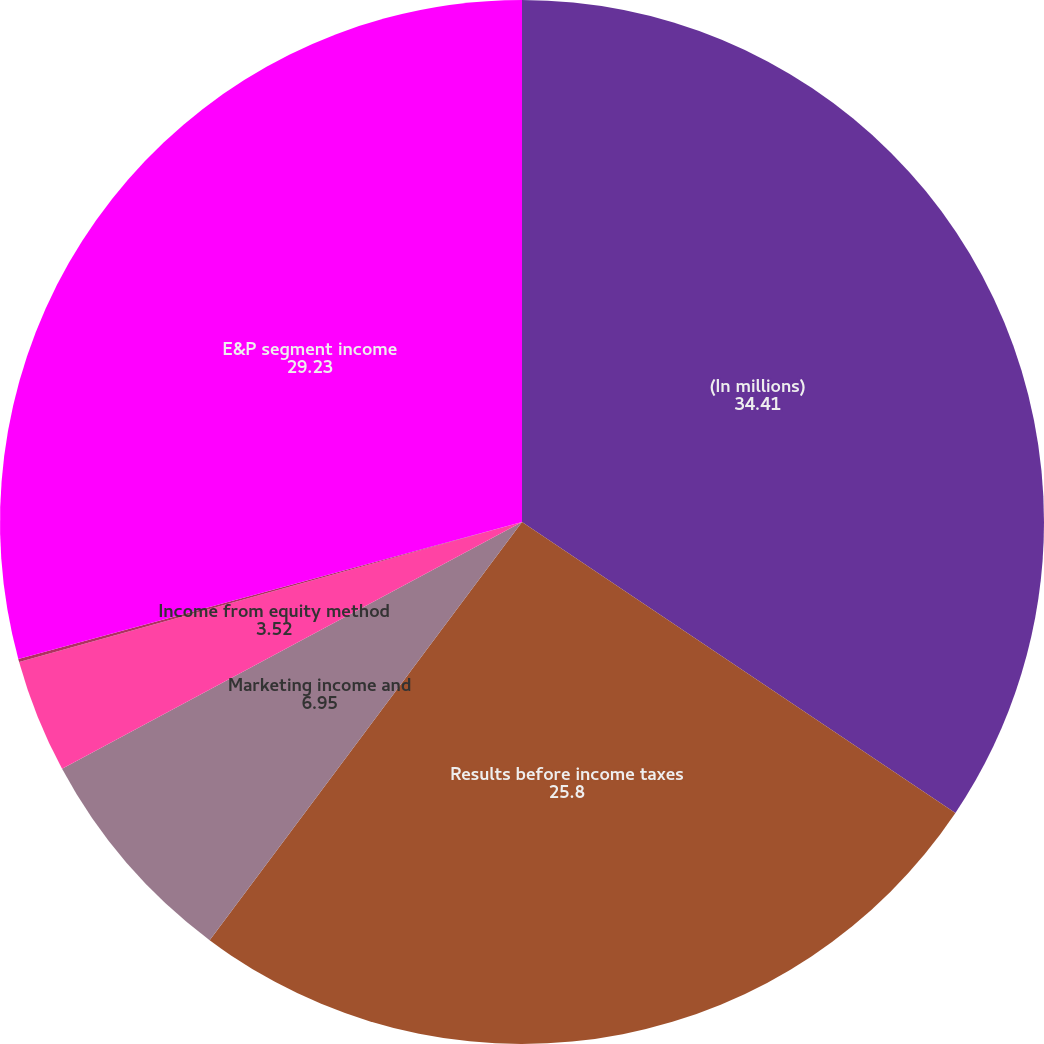Convert chart to OTSL. <chart><loc_0><loc_0><loc_500><loc_500><pie_chart><fcel>(In millions)<fcel>Results before income taxes<fcel>Marketing income and<fcel>Income from equity method<fcel>Other<fcel>E&P segment income<nl><fcel>34.41%<fcel>25.8%<fcel>6.95%<fcel>3.52%<fcel>0.09%<fcel>29.23%<nl></chart> 